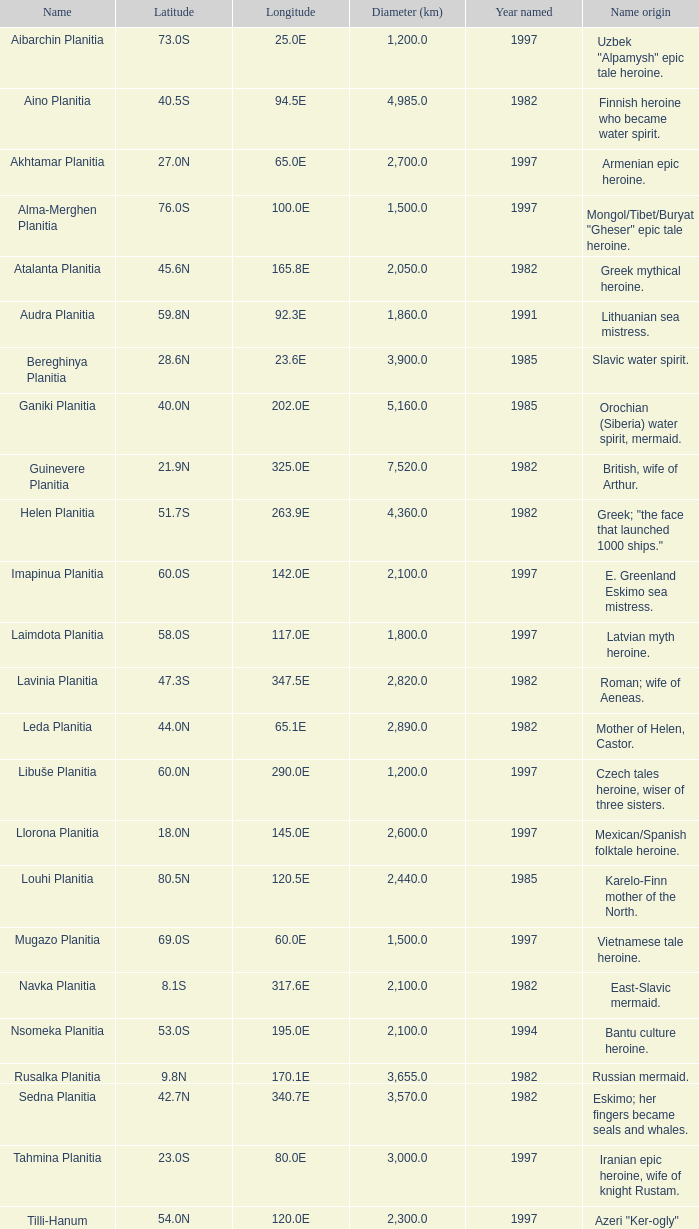What is the distance across (km) at longitude 17 3655.0. 